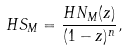Convert formula to latex. <formula><loc_0><loc_0><loc_500><loc_500>H S _ { M } = \frac { H N _ { M } ( z ) } { ( 1 - z ) ^ { n } } ,</formula> 